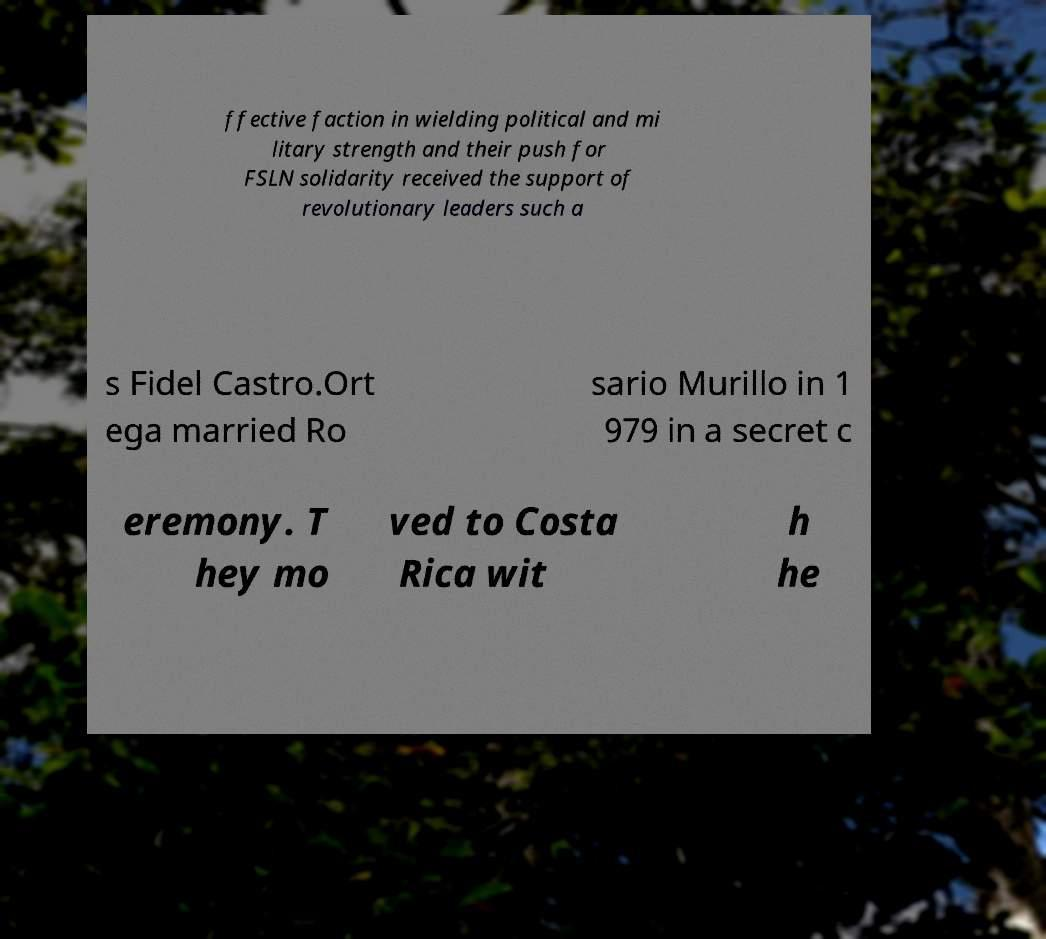Can you read and provide the text displayed in the image?This photo seems to have some interesting text. Can you extract and type it out for me? ffective faction in wielding political and mi litary strength and their push for FSLN solidarity received the support of revolutionary leaders such a s Fidel Castro.Ort ega married Ro sario Murillo in 1 979 in a secret c eremony. T hey mo ved to Costa Rica wit h he 